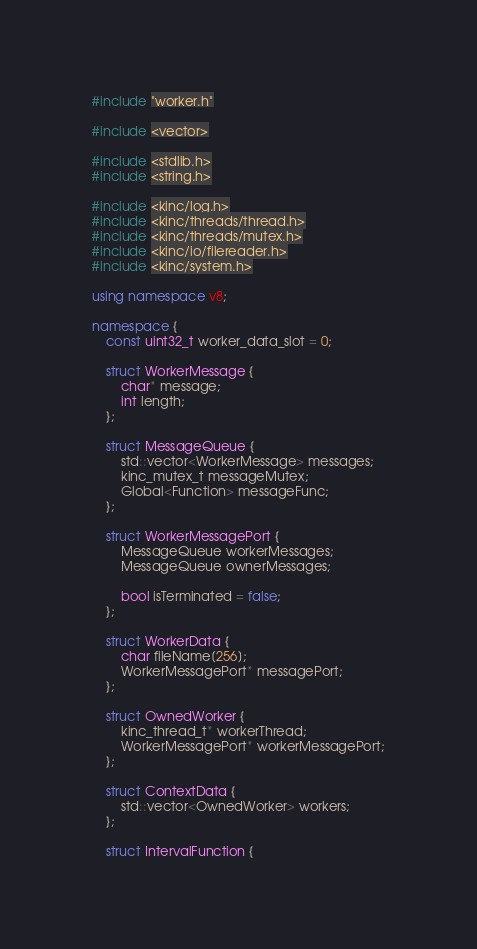Convert code to text. <code><loc_0><loc_0><loc_500><loc_500><_C++_>#include "worker.h"

#include <vector>

#include <stdlib.h>
#include <string.h>

#include <kinc/log.h>
#include <kinc/threads/thread.h>
#include <kinc/threads/mutex.h>
#include <kinc/io/filereader.h>
#include <kinc/system.h>

using namespace v8;

namespace {
	const uint32_t worker_data_slot = 0;

	struct WorkerMessage {
		char* message;
		int length;
	};

	struct MessageQueue {
		std::vector<WorkerMessage> messages;
		kinc_mutex_t messageMutex;
		Global<Function> messageFunc;
	};

	struct WorkerMessagePort {
		MessageQueue workerMessages;
		MessageQueue ownerMessages;

		bool isTerminated = false;
	};

	struct WorkerData {
		char fileName[256];
		WorkerMessagePort* messagePort;
	};

	struct OwnedWorker {
		kinc_thread_t* workerThread;
		WorkerMessagePort* workerMessagePort;
	};

	struct ContextData {
		std::vector<OwnedWorker> workers;
	};

	struct IntervalFunction {</code> 